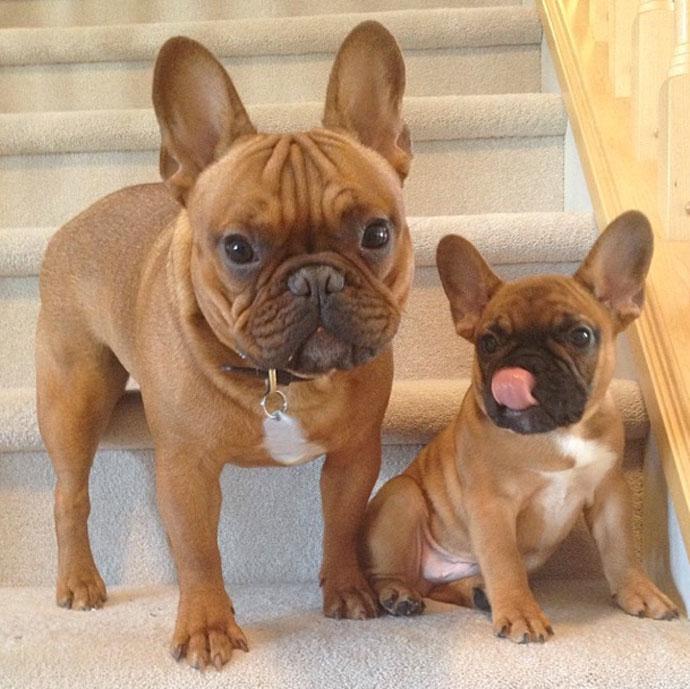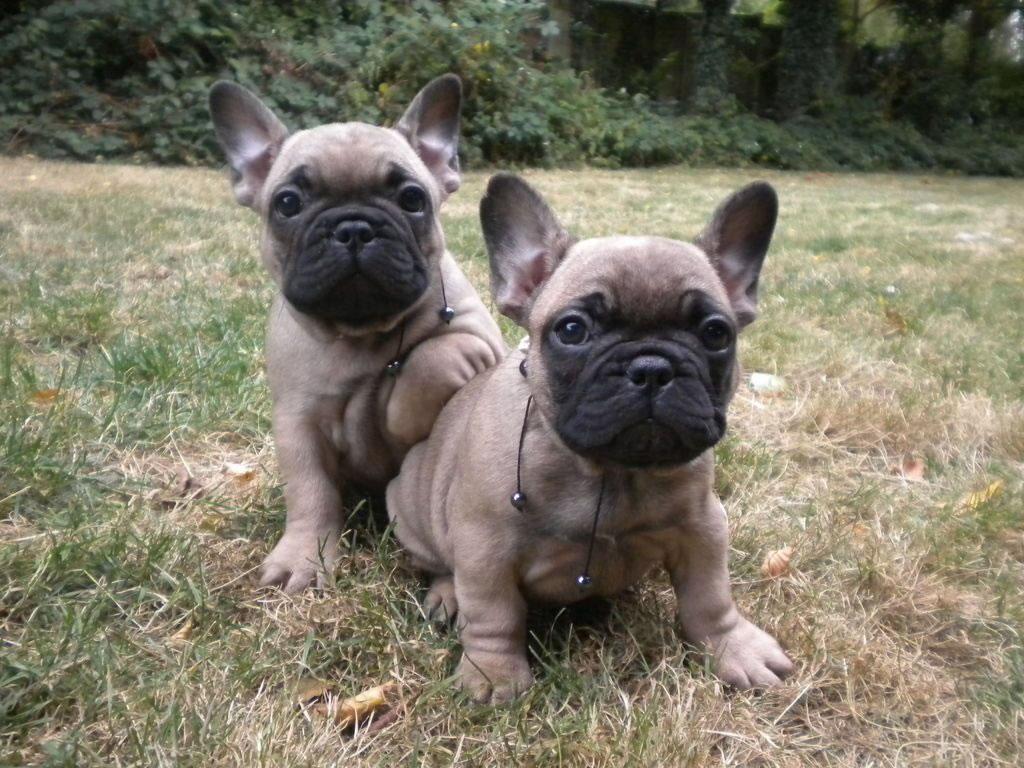The first image is the image on the left, the second image is the image on the right. Assess this claim about the two images: "Each image contains two big-eared dogs, and one pair of dogs includes a mostly black one and a mostly white one.". Correct or not? Answer yes or no. No. The first image is the image on the left, the second image is the image on the right. Analyze the images presented: Is the assertion "Two dogs are standing up in one of the images." valid? Answer yes or no. No. 